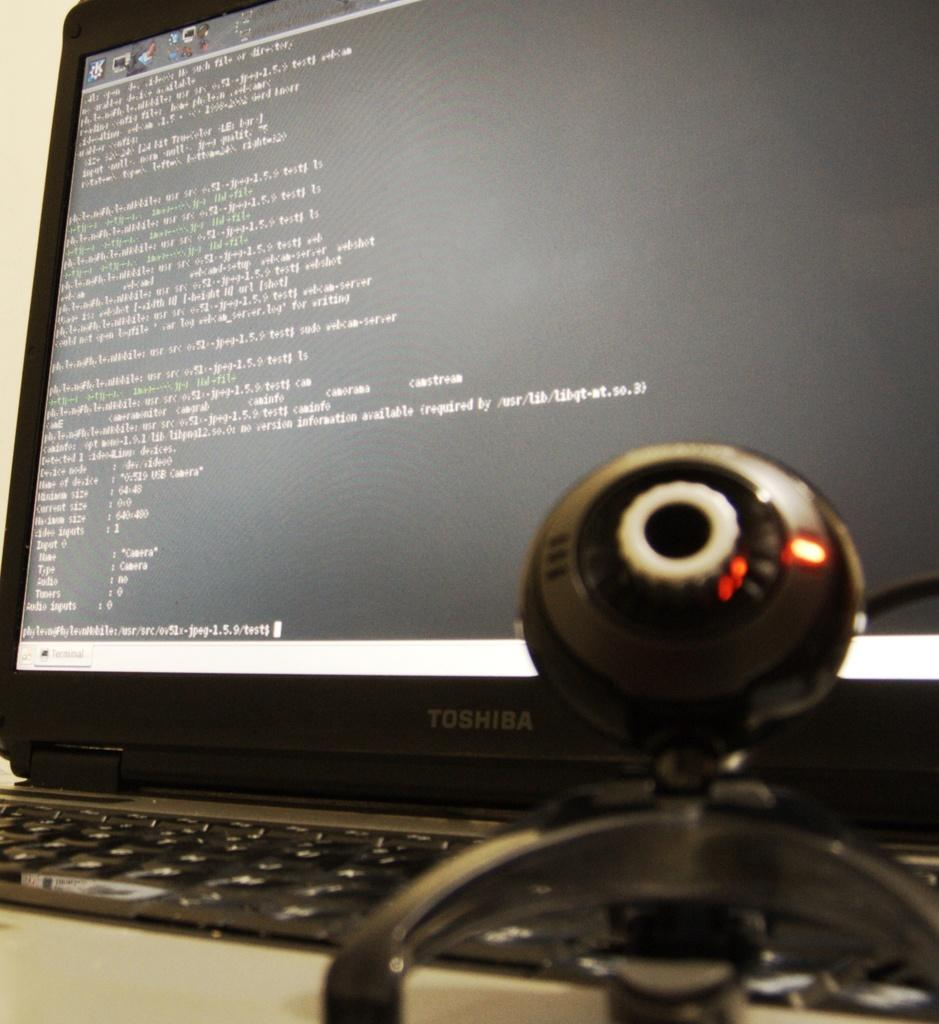<image>
Write a terse but informative summary of the picture. The black computer monitor being used here is a Toshiba 